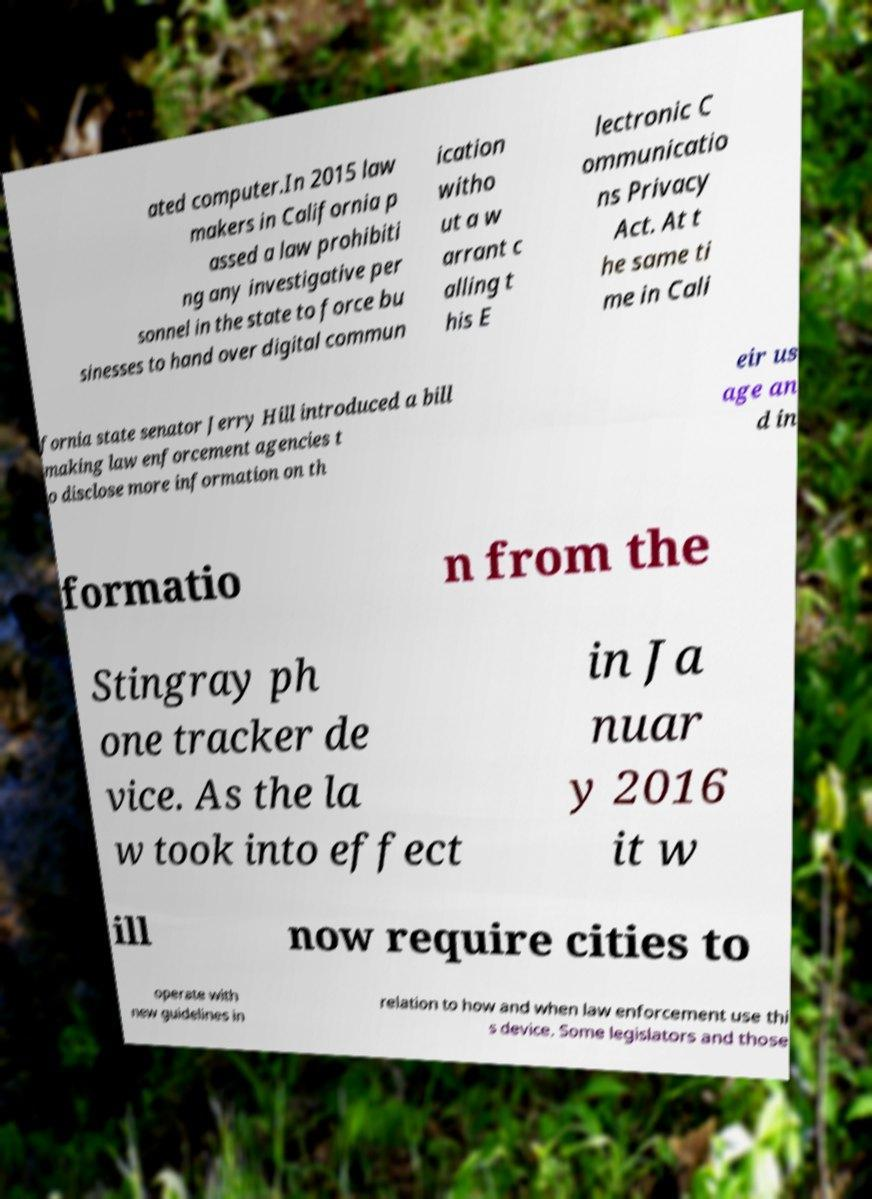Please read and relay the text visible in this image. What does it say? ated computer.In 2015 law makers in California p assed a law prohibiti ng any investigative per sonnel in the state to force bu sinesses to hand over digital commun ication witho ut a w arrant c alling t his E lectronic C ommunicatio ns Privacy Act. At t he same ti me in Cali fornia state senator Jerry Hill introduced a bill making law enforcement agencies t o disclose more information on th eir us age an d in formatio n from the Stingray ph one tracker de vice. As the la w took into effect in Ja nuar y 2016 it w ill now require cities to operate with new guidelines in relation to how and when law enforcement use thi s device. Some legislators and those 